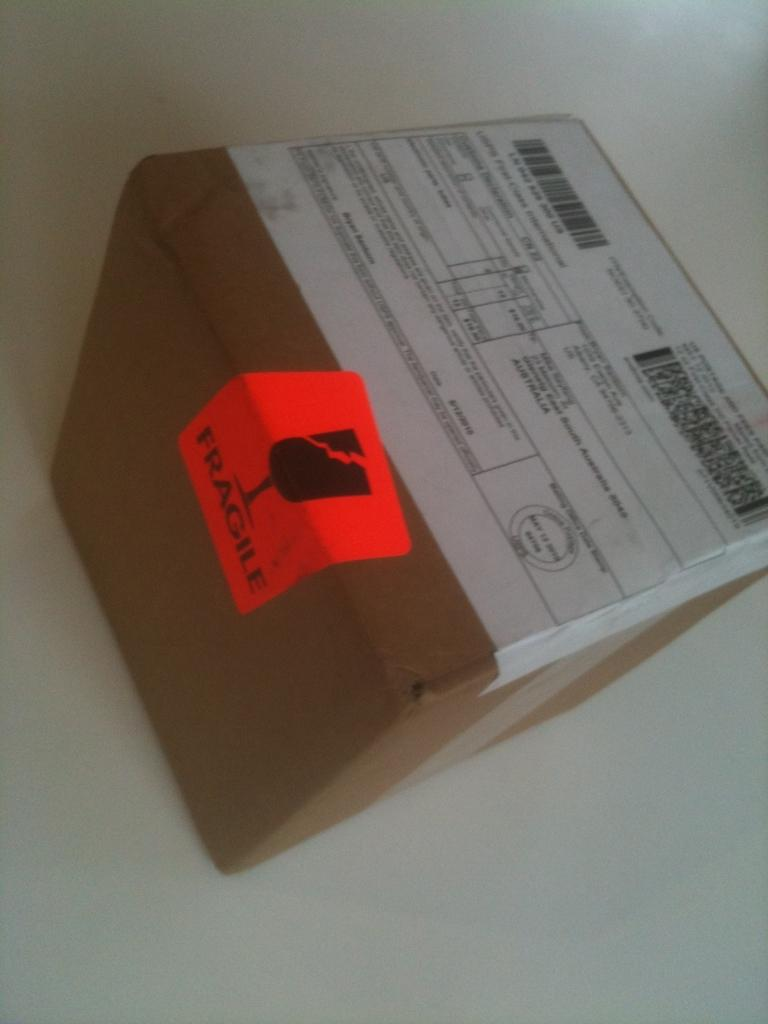What object is present in the image that is made of cardboard? There is a cardboard box in the image. What decorations are on the cardboard box? The cardboard box has stickers on it. What is the color of the background in the image? The background behind the cardboard box is white. How many rings are stacked on top of each other in the image? There are no rings present in the image. 